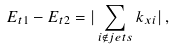Convert formula to latex. <formula><loc_0><loc_0><loc_500><loc_500>E _ { t 1 } - E _ { t 2 } = | \sum _ { i \notin j e t s } k _ { x i } | \, ,</formula> 